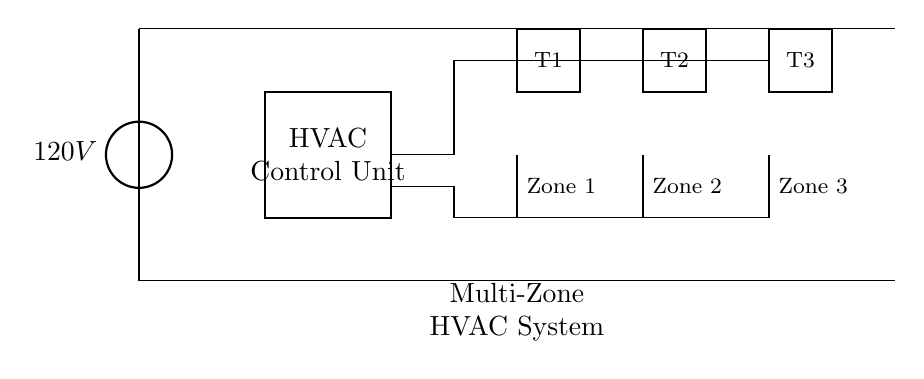What is the voltage of this circuit? The voltage is 120V, which is indicated by the voltage source in the circuit diagram.
Answer: 120V What components control the heating and cooling in this system? The HVAC Control Unit is responsible for managing the overall heating and cooling systems. This control unit interacts with the thermostats to regulate temperature.
Answer: HVAC Control Unit How many thermostats are there in this circuit? There are three thermostats in the circuit, labeled T1, T2, and T3, corresponding to the different zones served by the HVAC system.
Answer: Three What does the abbreviation "elmech" represent in this diagram? "Elmech" stands for electronic mechanical valve, used to control the flow of heating or cooling fluid to each separate zone in the HVAC system.
Answer: Electronic mechanical valve Which zones are being controlled by the thermostats? The zones controlled are Zone 1, Zone 2, and Zone 3, indicated next to each electronic mechanical valve in the diagram.
Answer: Zone 1, Zone 2, Zone 3 Explain how the thermostats are connected to the HVAC Control Unit. The thermostats (T1, T2, T3) are connected to the HVAC Control Unit through connecting lines which establish an electrical signal path. This allows the control unit to receive temperature readings from each thermostat.
Answer: Via connecting lines What is the purpose of the multi-zone HVAC system indicated in the diagram? The purpose is to allow different areas (or zones) of a building to maintain separate temperatures based on the preferences registered by each thermostat, enhancing comfort and energy efficiency.
Answer: To maintain separate temperatures 